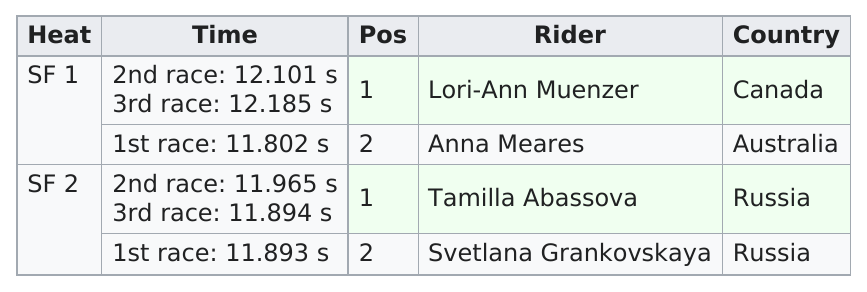Point out several critical features in this image. Russia was the country that had women who placed both first and second in the semifinals. Anna Meares had the best time among all women. 